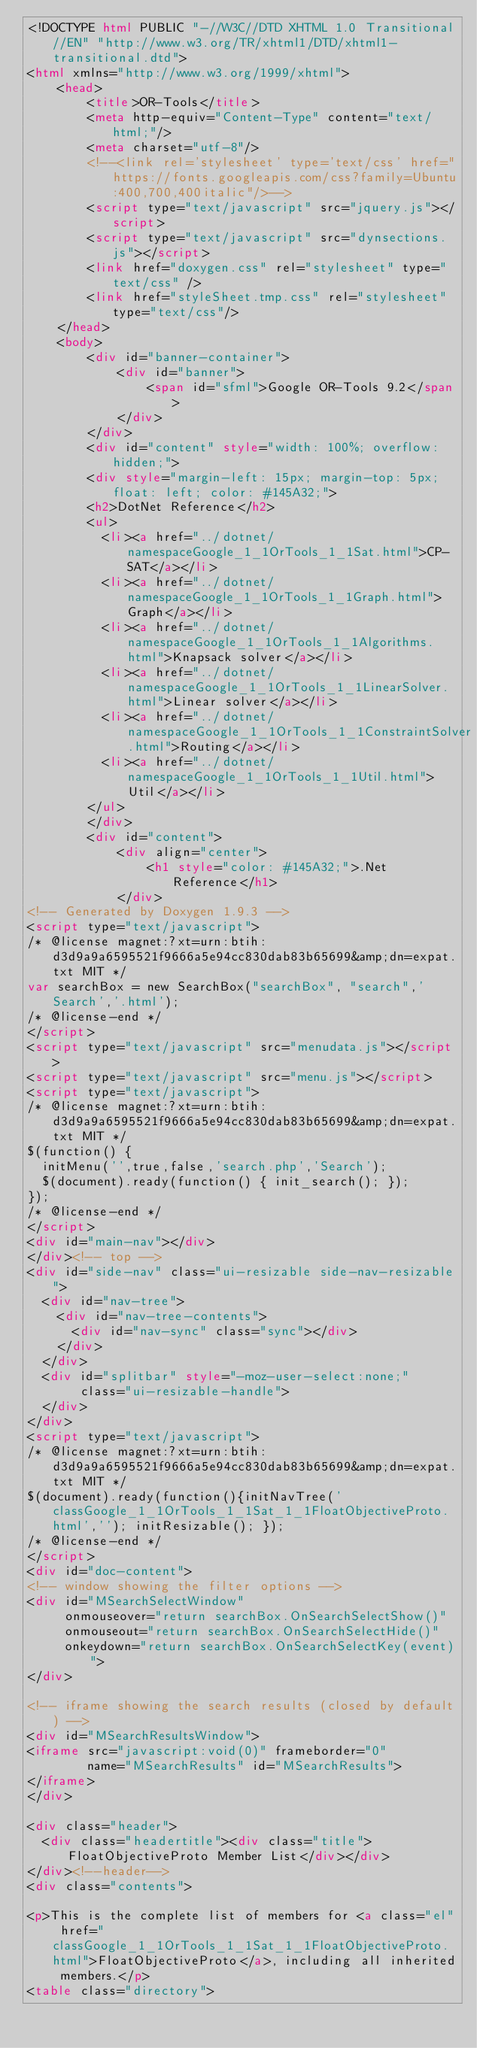Convert code to text. <code><loc_0><loc_0><loc_500><loc_500><_HTML_><!DOCTYPE html PUBLIC "-//W3C//DTD XHTML 1.0 Transitional//EN" "http://www.w3.org/TR/xhtml1/DTD/xhtml1-transitional.dtd">
<html xmlns="http://www.w3.org/1999/xhtml">
    <head>
        <title>OR-Tools</title>
        <meta http-equiv="Content-Type" content="text/html;"/>
        <meta charset="utf-8"/>
        <!--<link rel='stylesheet' type='text/css' href="https://fonts.googleapis.com/css?family=Ubuntu:400,700,400italic"/>-->
        <script type="text/javascript" src="jquery.js"></script>
        <script type="text/javascript" src="dynsections.js"></script>
        <link href="doxygen.css" rel="stylesheet" type="text/css" />
        <link href="styleSheet.tmp.css" rel="stylesheet" type="text/css"/>
    </head>
    <body>
        <div id="banner-container">
            <div id="banner">
                <span id="sfml">Google OR-Tools 9.2</span>
            </div>
        </div>
        <div id="content" style="width: 100%; overflow: hidden;">
        <div style="margin-left: 15px; margin-top: 5px; float: left; color: #145A32;">
        <h2>DotNet Reference</h2>
        <ul>
          <li><a href="../dotnet/namespaceGoogle_1_1OrTools_1_1Sat.html">CP-SAT</a></li>
          <li><a href="../dotnet/namespaceGoogle_1_1OrTools_1_1Graph.html">Graph</a></li>
          <li><a href="../dotnet/namespaceGoogle_1_1OrTools_1_1Algorithms.html">Knapsack solver</a></li>
          <li><a href="../dotnet/namespaceGoogle_1_1OrTools_1_1LinearSolver.html">Linear solver</a></li>
          <li><a href="../dotnet/namespaceGoogle_1_1OrTools_1_1ConstraintSolver.html">Routing</a></li>
          <li><a href="../dotnet/namespaceGoogle_1_1OrTools_1_1Util.html">Util</a></li>
        </ul>
        </div>
        <div id="content">
            <div align="center">
                <h1 style="color: #145A32;">.Net Reference</h1>
            </div>
<!-- Generated by Doxygen 1.9.3 -->
<script type="text/javascript">
/* @license magnet:?xt=urn:btih:d3d9a9a6595521f9666a5e94cc830dab83b65699&amp;dn=expat.txt MIT */
var searchBox = new SearchBox("searchBox", "search",'Search','.html');
/* @license-end */
</script>
<script type="text/javascript" src="menudata.js"></script>
<script type="text/javascript" src="menu.js"></script>
<script type="text/javascript">
/* @license magnet:?xt=urn:btih:d3d9a9a6595521f9666a5e94cc830dab83b65699&amp;dn=expat.txt MIT */
$(function() {
  initMenu('',true,false,'search.php','Search');
  $(document).ready(function() { init_search(); });
});
/* @license-end */
</script>
<div id="main-nav"></div>
</div><!-- top -->
<div id="side-nav" class="ui-resizable side-nav-resizable">
  <div id="nav-tree">
    <div id="nav-tree-contents">
      <div id="nav-sync" class="sync"></div>
    </div>
  </div>
  <div id="splitbar" style="-moz-user-select:none;" 
       class="ui-resizable-handle">
  </div>
</div>
<script type="text/javascript">
/* @license magnet:?xt=urn:btih:d3d9a9a6595521f9666a5e94cc830dab83b65699&amp;dn=expat.txt MIT */
$(document).ready(function(){initNavTree('classGoogle_1_1OrTools_1_1Sat_1_1FloatObjectiveProto.html',''); initResizable(); });
/* @license-end */
</script>
<div id="doc-content">
<!-- window showing the filter options -->
<div id="MSearchSelectWindow"
     onmouseover="return searchBox.OnSearchSelectShow()"
     onmouseout="return searchBox.OnSearchSelectHide()"
     onkeydown="return searchBox.OnSearchSelectKey(event)">
</div>

<!-- iframe showing the search results (closed by default) -->
<div id="MSearchResultsWindow">
<iframe src="javascript:void(0)" frameborder="0" 
        name="MSearchResults" id="MSearchResults">
</iframe>
</div>

<div class="header">
  <div class="headertitle"><div class="title">FloatObjectiveProto Member List</div></div>
</div><!--header-->
<div class="contents">

<p>This is the complete list of members for <a class="el" href="classGoogle_1_1OrTools_1_1Sat_1_1FloatObjectiveProto.html">FloatObjectiveProto</a>, including all inherited members.</p>
<table class="directory"></code> 